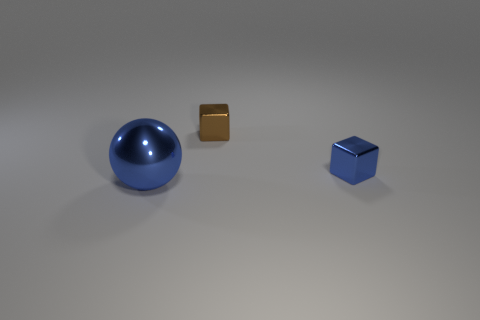Add 3 big brown metal balls. How many objects exist? 6 Subtract all cubes. How many objects are left? 1 Subtract 0 yellow cylinders. How many objects are left? 3 Subtract all small blue blocks. Subtract all small blue metal things. How many objects are left? 1 Add 1 small brown things. How many small brown things are left? 2 Add 2 tiny blue rubber cylinders. How many tiny blue rubber cylinders exist? 2 